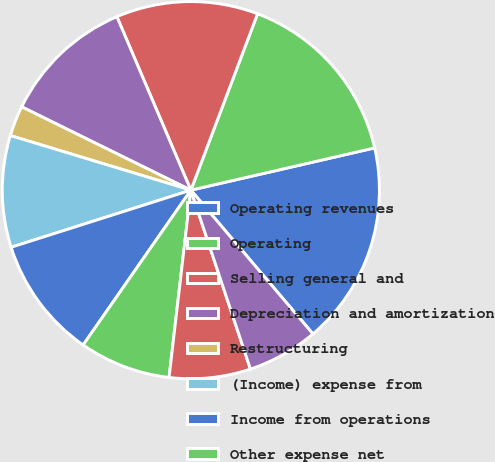<chart> <loc_0><loc_0><loc_500><loc_500><pie_chart><fcel>Operating revenues<fcel>Operating<fcel>Selling general and<fcel>Depreciation and amortization<fcel>Restructuring<fcel>(Income) expense from<fcel>Income from operations<fcel>Other expense net<fcel>Income before income taxes<fcel>Provision for income taxes<nl><fcel>17.39%<fcel>15.65%<fcel>12.17%<fcel>11.3%<fcel>2.61%<fcel>9.57%<fcel>10.43%<fcel>7.83%<fcel>6.96%<fcel>6.09%<nl></chart> 